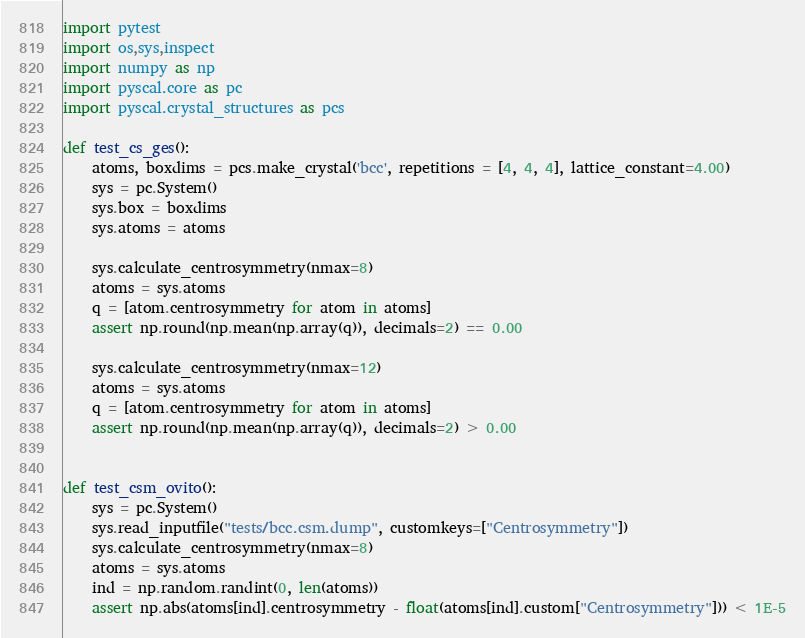<code> <loc_0><loc_0><loc_500><loc_500><_Python_>import pytest
import os,sys,inspect
import numpy as np
import pyscal.core as pc
import pyscal.crystal_structures as pcs

def test_cs_ges():
    atoms, boxdims = pcs.make_crystal('bcc', repetitions = [4, 4, 4], lattice_constant=4.00)
    sys = pc.System()
    sys.box = boxdims
    sys.atoms = atoms

    sys.calculate_centrosymmetry(nmax=8)
    atoms = sys.atoms
    q = [atom.centrosymmetry for atom in atoms]
    assert np.round(np.mean(np.array(q)), decimals=2) == 0.00

    sys.calculate_centrosymmetry(nmax=12)
    atoms = sys.atoms
    q = [atom.centrosymmetry for atom in atoms]
    assert np.round(np.mean(np.array(q)), decimals=2) > 0.00


def test_csm_ovito():
    sys = pc.System()
    sys.read_inputfile("tests/bcc.csm.dump", customkeys=["Centrosymmetry"])    
    sys.calculate_centrosymmetry(nmax=8)
    atoms = sys.atoms
    ind = np.random.randint(0, len(atoms))
    assert np.abs(atoms[ind].centrosymmetry - float(atoms[ind].custom["Centrosymmetry"])) < 1E-5
</code> 